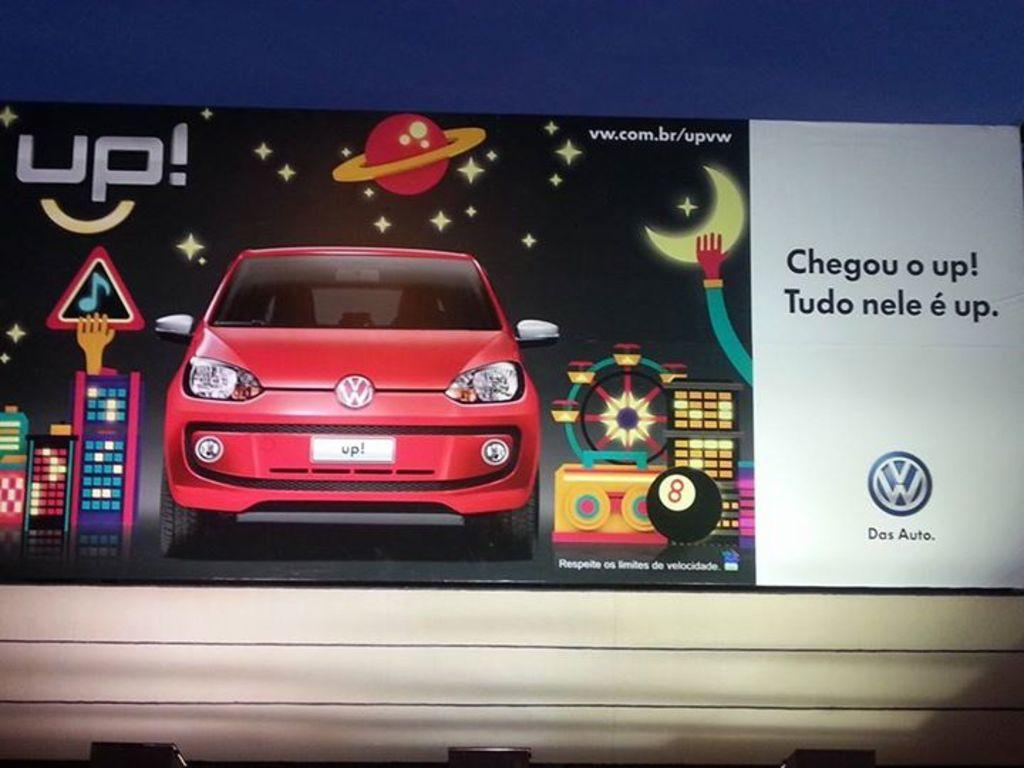What is the main subject of the image? The main subject of the image is an advertisement of a car. What type of furniture is shown in the image? There is no furniture present in the image; it features an advertisement of a car. What letters are visible on the car in the image? The provided facts do not mention any specific letters on the car, so we cannot answer this question definitively. 